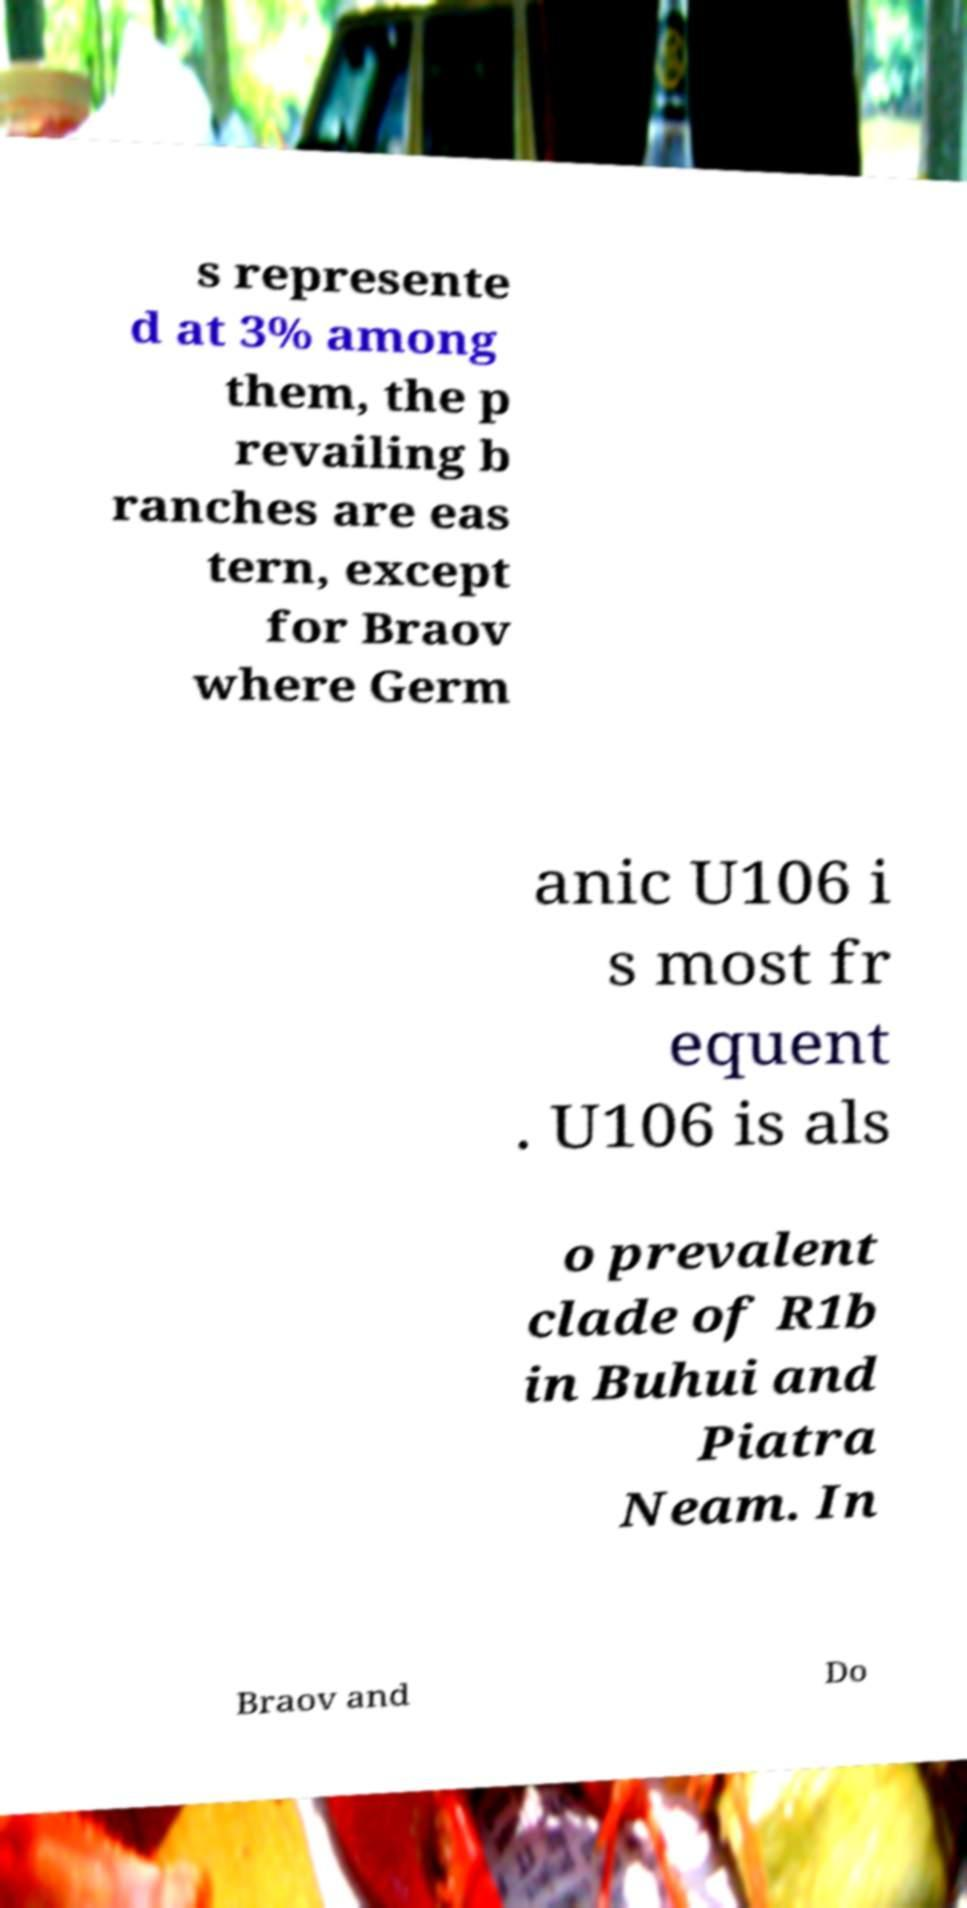Can you read and provide the text displayed in the image?This photo seems to have some interesting text. Can you extract and type it out for me? s represente d at 3% among them, the p revailing b ranches are eas tern, except for Braov where Germ anic U106 i s most fr equent . U106 is als o prevalent clade of R1b in Buhui and Piatra Neam. In Braov and Do 